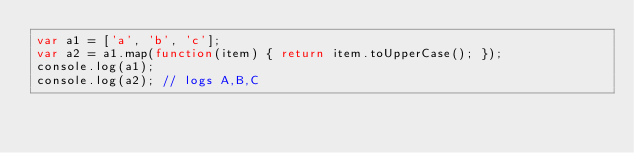<code> <loc_0><loc_0><loc_500><loc_500><_JavaScript_>var a1 = ['a', 'b', 'c'];
var a2 = a1.map(function(item) { return item.toUpperCase(); });
console.log(a1);
console.log(a2); // logs A,B,C</code> 